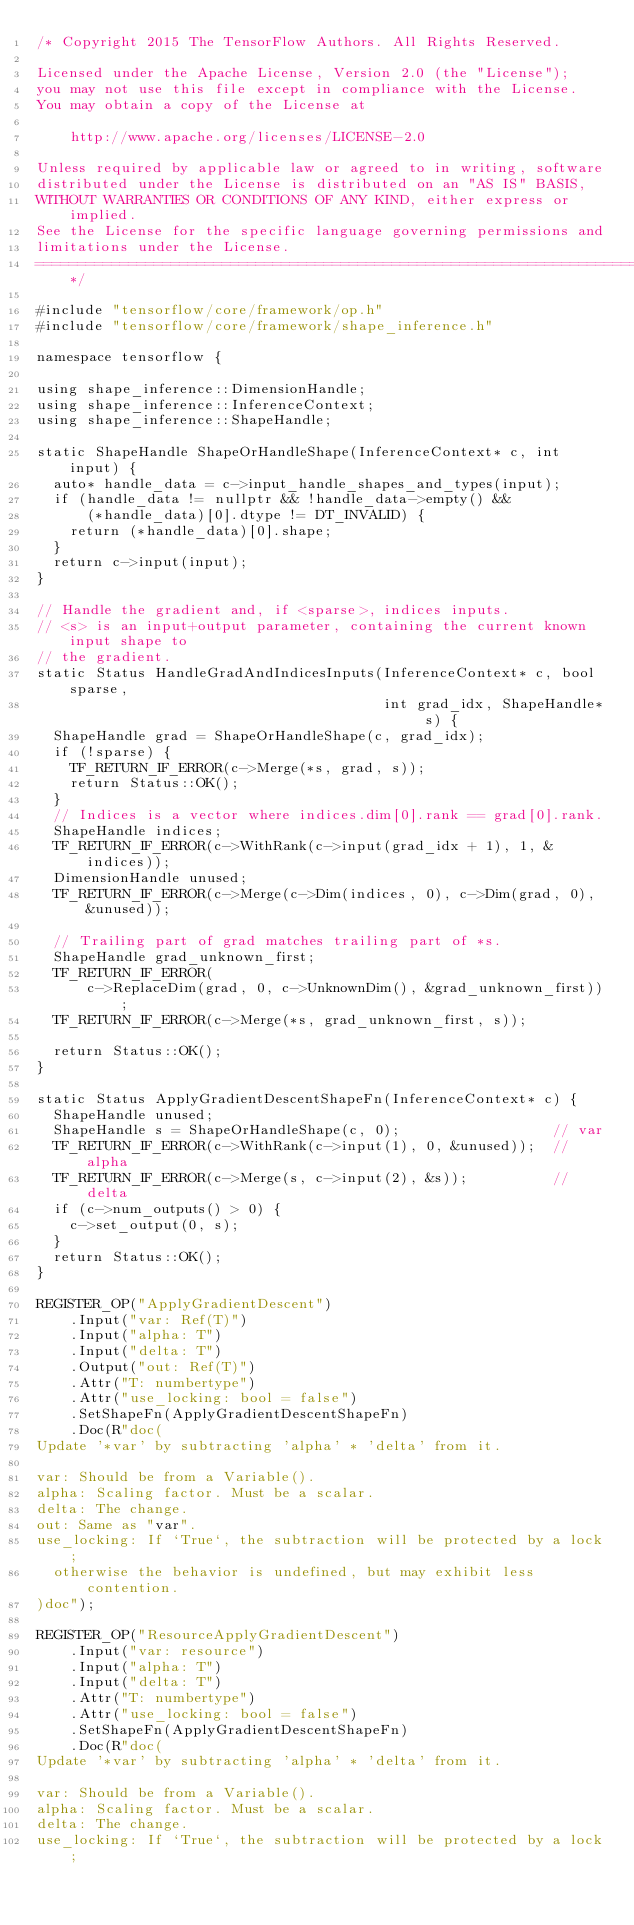Convert code to text. <code><loc_0><loc_0><loc_500><loc_500><_C++_>/* Copyright 2015 The TensorFlow Authors. All Rights Reserved.

Licensed under the Apache License, Version 2.0 (the "License");
you may not use this file except in compliance with the License.
You may obtain a copy of the License at

    http://www.apache.org/licenses/LICENSE-2.0

Unless required by applicable law or agreed to in writing, software
distributed under the License is distributed on an "AS IS" BASIS,
WITHOUT WARRANTIES OR CONDITIONS OF ANY KIND, either express or implied.
See the License for the specific language governing permissions and
limitations under the License.
==============================================================================*/

#include "tensorflow/core/framework/op.h"
#include "tensorflow/core/framework/shape_inference.h"

namespace tensorflow {

using shape_inference::DimensionHandle;
using shape_inference::InferenceContext;
using shape_inference::ShapeHandle;

static ShapeHandle ShapeOrHandleShape(InferenceContext* c, int input) {
  auto* handle_data = c->input_handle_shapes_and_types(input);
  if (handle_data != nullptr && !handle_data->empty() &&
      (*handle_data)[0].dtype != DT_INVALID) {
    return (*handle_data)[0].shape;
  }
  return c->input(input);
}

// Handle the gradient and, if <sparse>, indices inputs.
// <s> is an input+output parameter, containing the current known input shape to
// the gradient.
static Status HandleGradAndIndicesInputs(InferenceContext* c, bool sparse,
                                         int grad_idx, ShapeHandle* s) {
  ShapeHandle grad = ShapeOrHandleShape(c, grad_idx);
  if (!sparse) {
    TF_RETURN_IF_ERROR(c->Merge(*s, grad, s));
    return Status::OK();
  }
  // Indices is a vector where indices.dim[0].rank == grad[0].rank.
  ShapeHandle indices;
  TF_RETURN_IF_ERROR(c->WithRank(c->input(grad_idx + 1), 1, &indices));
  DimensionHandle unused;
  TF_RETURN_IF_ERROR(c->Merge(c->Dim(indices, 0), c->Dim(grad, 0), &unused));

  // Trailing part of grad matches trailing part of *s.
  ShapeHandle grad_unknown_first;
  TF_RETURN_IF_ERROR(
      c->ReplaceDim(grad, 0, c->UnknownDim(), &grad_unknown_first));
  TF_RETURN_IF_ERROR(c->Merge(*s, grad_unknown_first, s));

  return Status::OK();
}

static Status ApplyGradientDescentShapeFn(InferenceContext* c) {
  ShapeHandle unused;
  ShapeHandle s = ShapeOrHandleShape(c, 0);                  // var
  TF_RETURN_IF_ERROR(c->WithRank(c->input(1), 0, &unused));  // alpha
  TF_RETURN_IF_ERROR(c->Merge(s, c->input(2), &s));          // delta
  if (c->num_outputs() > 0) {
    c->set_output(0, s);
  }
  return Status::OK();
}

REGISTER_OP("ApplyGradientDescent")
    .Input("var: Ref(T)")
    .Input("alpha: T")
    .Input("delta: T")
    .Output("out: Ref(T)")
    .Attr("T: numbertype")
    .Attr("use_locking: bool = false")
    .SetShapeFn(ApplyGradientDescentShapeFn)
    .Doc(R"doc(
Update '*var' by subtracting 'alpha' * 'delta' from it.

var: Should be from a Variable().
alpha: Scaling factor. Must be a scalar.
delta: The change.
out: Same as "var".
use_locking: If `True`, the subtraction will be protected by a lock;
  otherwise the behavior is undefined, but may exhibit less contention.
)doc");

REGISTER_OP("ResourceApplyGradientDescent")
    .Input("var: resource")
    .Input("alpha: T")
    .Input("delta: T")
    .Attr("T: numbertype")
    .Attr("use_locking: bool = false")
    .SetShapeFn(ApplyGradientDescentShapeFn)
    .Doc(R"doc(
Update '*var' by subtracting 'alpha' * 'delta' from it.

var: Should be from a Variable().
alpha: Scaling factor. Must be a scalar.
delta: The change.
use_locking: If `True`, the subtraction will be protected by a lock;</code> 